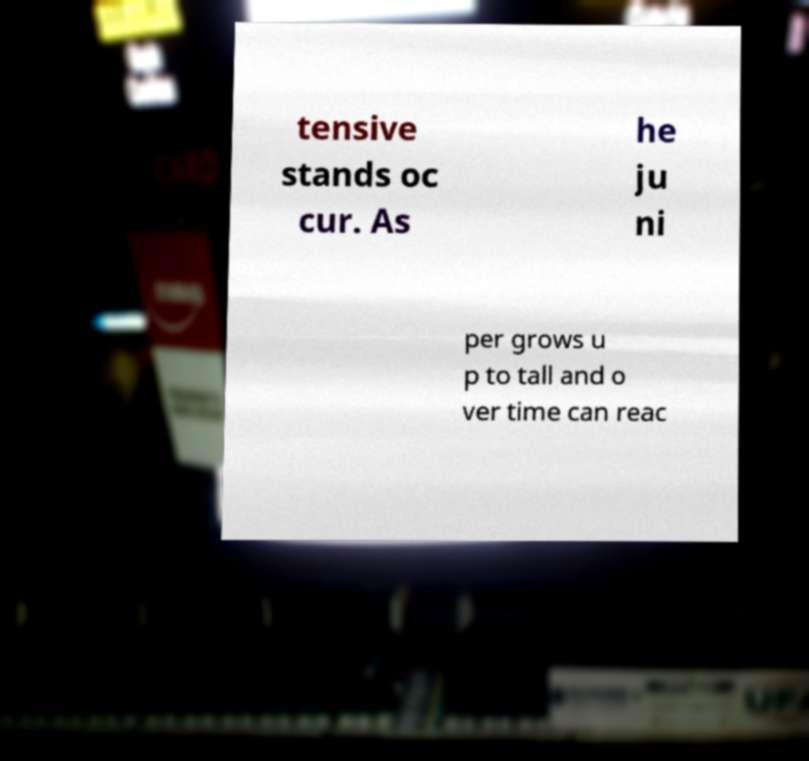Please identify and transcribe the text found in this image. tensive stands oc cur. As he ju ni per grows u p to tall and o ver time can reac 